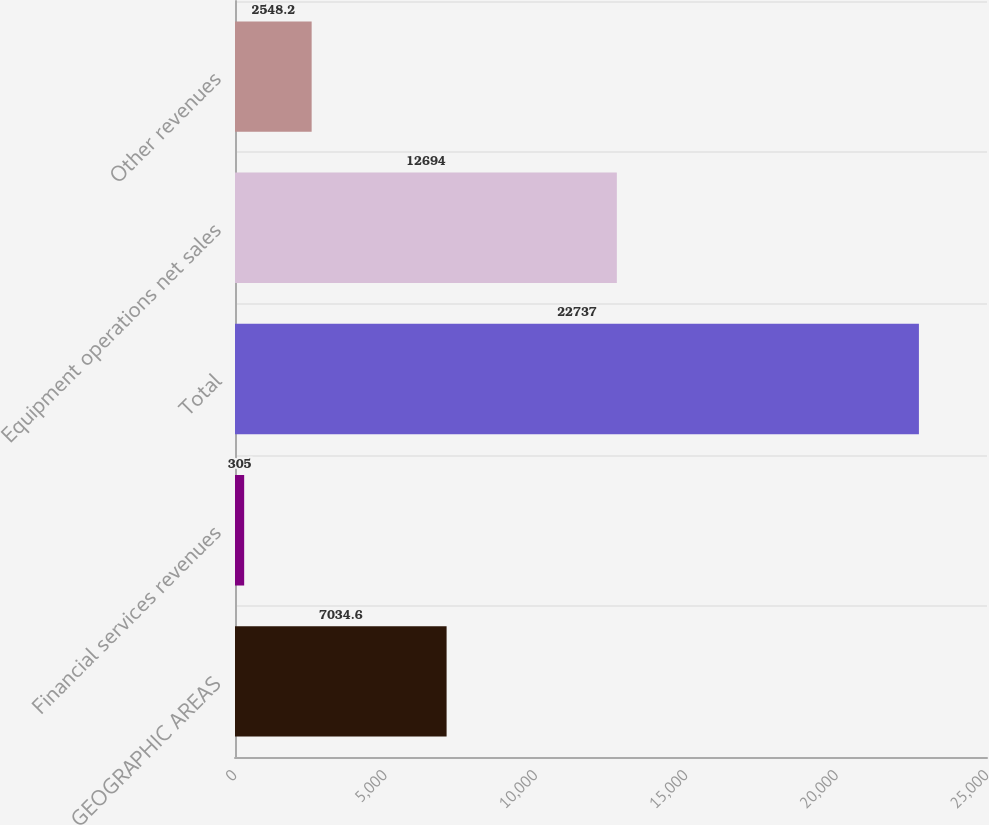<chart> <loc_0><loc_0><loc_500><loc_500><bar_chart><fcel>GEOGRAPHIC AREAS<fcel>Financial services revenues<fcel>Total<fcel>Equipment operations net sales<fcel>Other revenues<nl><fcel>7034.6<fcel>305<fcel>22737<fcel>12694<fcel>2548.2<nl></chart> 